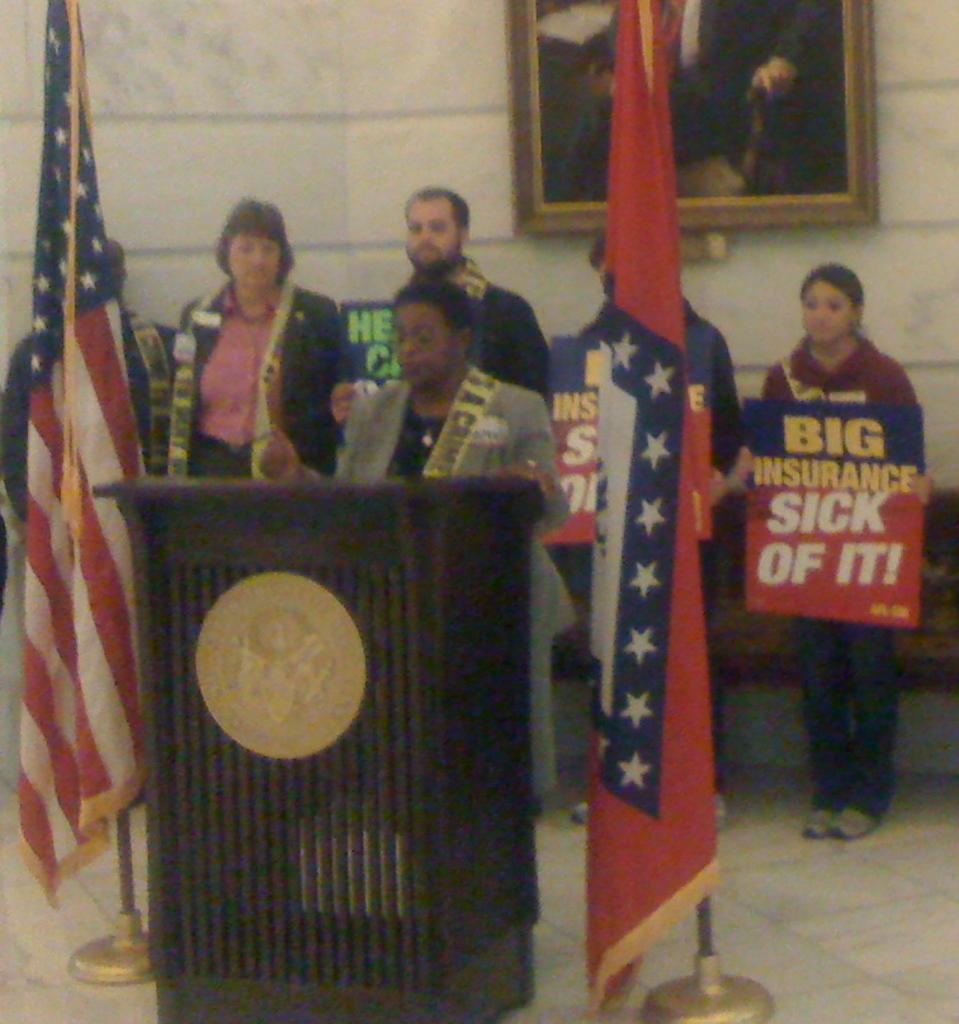<image>
Give a short and clear explanation of the subsequent image. A woman holds a sign protesting big insurance. 